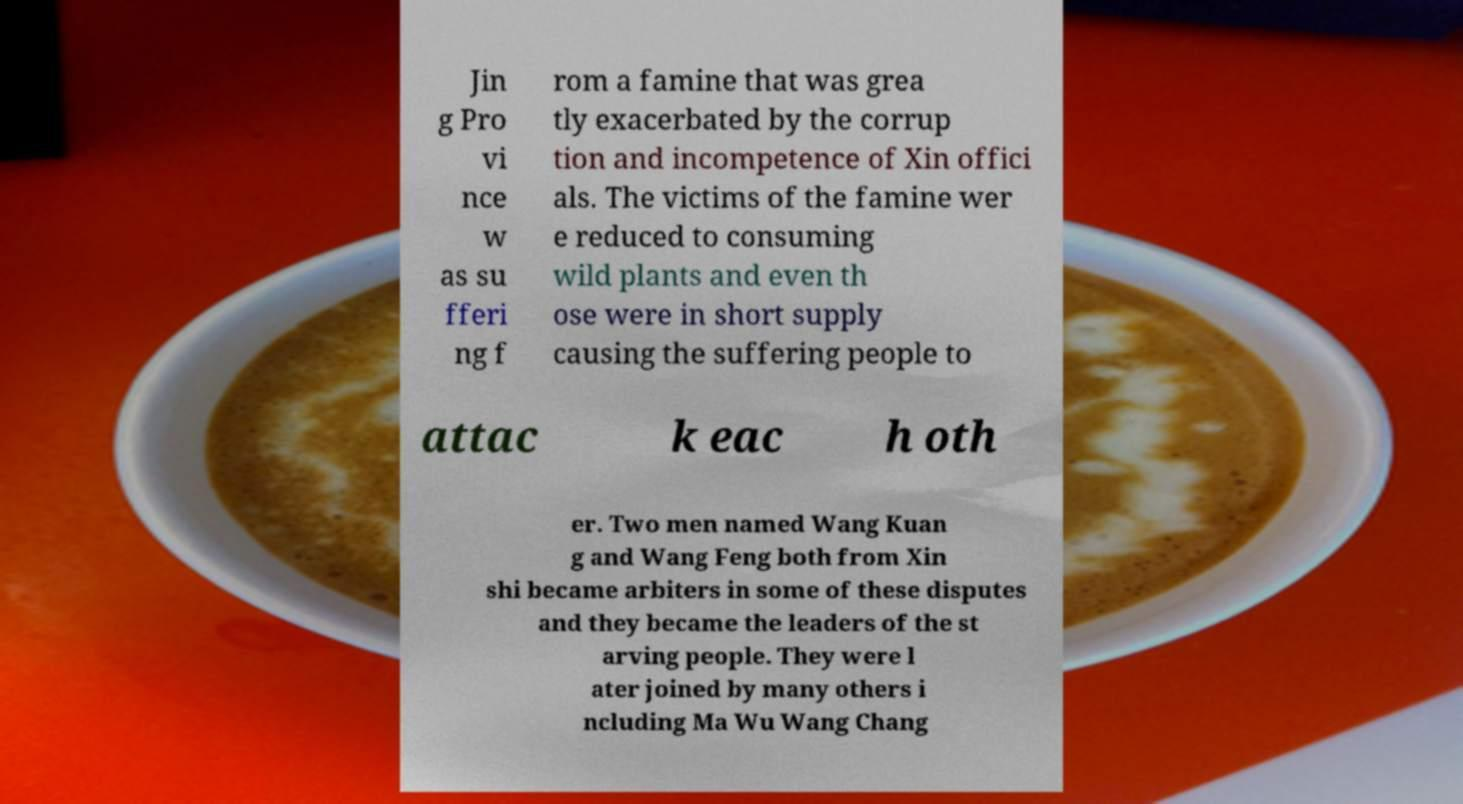What messages or text are displayed in this image? I need them in a readable, typed format. Jin g Pro vi nce w as su fferi ng f rom a famine that was grea tly exacerbated by the corrup tion and incompetence of Xin offici als. The victims of the famine wer e reduced to consuming wild plants and even th ose were in short supply causing the suffering people to attac k eac h oth er. Two men named Wang Kuan g and Wang Feng both from Xin shi became arbiters in some of these disputes and they became the leaders of the st arving people. They were l ater joined by many others i ncluding Ma Wu Wang Chang 